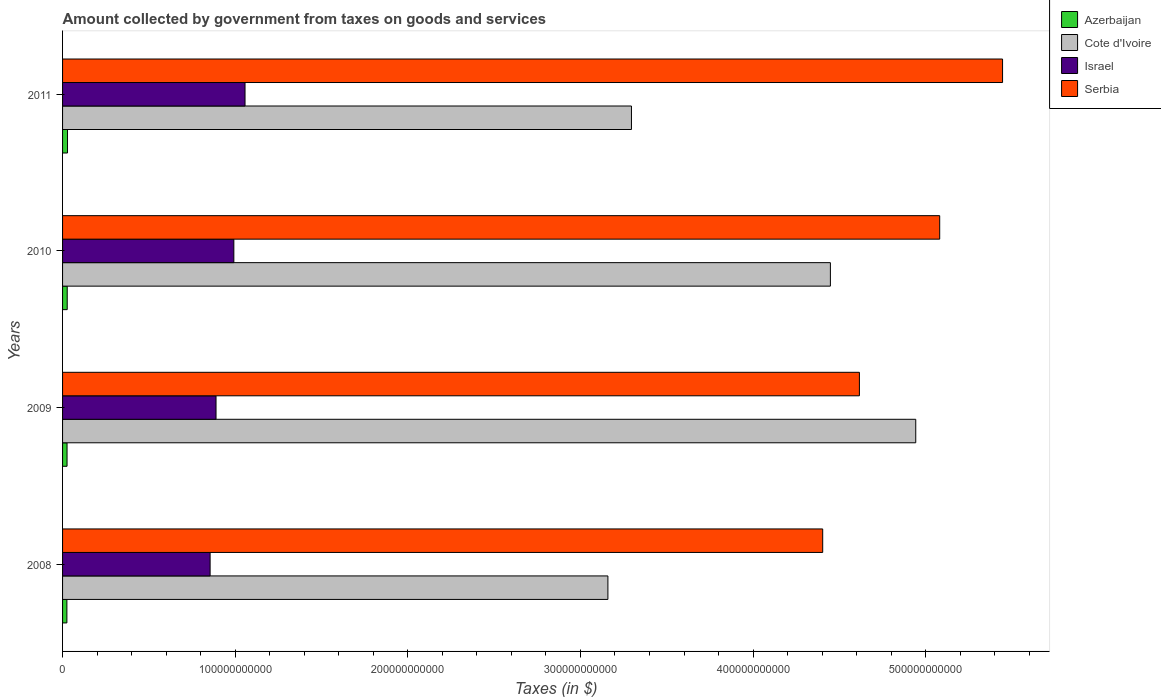How many bars are there on the 4th tick from the bottom?
Offer a very short reply. 4. What is the amount collected by government from taxes on goods and services in Israel in 2009?
Provide a succinct answer. 8.89e+1. Across all years, what is the maximum amount collected by government from taxes on goods and services in Azerbaijan?
Ensure brevity in your answer.  2.87e+09. Across all years, what is the minimum amount collected by government from taxes on goods and services in Azerbaijan?
Ensure brevity in your answer.  2.50e+09. What is the total amount collected by government from taxes on goods and services in Israel in the graph?
Keep it short and to the point. 3.79e+11. What is the difference between the amount collected by government from taxes on goods and services in Azerbaijan in 2008 and that in 2011?
Offer a terse response. -3.62e+08. What is the difference between the amount collected by government from taxes on goods and services in Azerbaijan in 2010 and the amount collected by government from taxes on goods and services in Cote d'Ivoire in 2011?
Make the answer very short. -3.27e+11. What is the average amount collected by government from taxes on goods and services in Azerbaijan per year?
Give a very brief answer. 2.66e+09. In the year 2009, what is the difference between the amount collected by government from taxes on goods and services in Serbia and amount collected by government from taxes on goods and services in Azerbaijan?
Provide a short and direct response. 4.59e+11. In how many years, is the amount collected by government from taxes on goods and services in Israel greater than 280000000000 $?
Provide a short and direct response. 0. What is the ratio of the amount collected by government from taxes on goods and services in Cote d'Ivoire in 2009 to that in 2010?
Your answer should be compact. 1.11. Is the difference between the amount collected by government from taxes on goods and services in Serbia in 2008 and 2009 greater than the difference between the amount collected by government from taxes on goods and services in Azerbaijan in 2008 and 2009?
Offer a terse response. No. What is the difference between the highest and the second highest amount collected by government from taxes on goods and services in Cote d'Ivoire?
Provide a short and direct response. 4.94e+1. What is the difference between the highest and the lowest amount collected by government from taxes on goods and services in Azerbaijan?
Keep it short and to the point. 3.62e+08. In how many years, is the amount collected by government from taxes on goods and services in Cote d'Ivoire greater than the average amount collected by government from taxes on goods and services in Cote d'Ivoire taken over all years?
Make the answer very short. 2. Is the sum of the amount collected by government from taxes on goods and services in Israel in 2008 and 2011 greater than the maximum amount collected by government from taxes on goods and services in Cote d'Ivoire across all years?
Keep it short and to the point. No. Is it the case that in every year, the sum of the amount collected by government from taxes on goods and services in Serbia and amount collected by government from taxes on goods and services in Israel is greater than the sum of amount collected by government from taxes on goods and services in Cote d'Ivoire and amount collected by government from taxes on goods and services in Azerbaijan?
Make the answer very short. Yes. What does the 1st bar from the bottom in 2008 represents?
Your answer should be compact. Azerbaijan. How many years are there in the graph?
Provide a short and direct response. 4. What is the difference between two consecutive major ticks on the X-axis?
Make the answer very short. 1.00e+11. Does the graph contain any zero values?
Give a very brief answer. No. Does the graph contain grids?
Your answer should be compact. No. How many legend labels are there?
Offer a very short reply. 4. How are the legend labels stacked?
Give a very brief answer. Vertical. What is the title of the graph?
Offer a terse response. Amount collected by government from taxes on goods and services. What is the label or title of the X-axis?
Provide a short and direct response. Taxes (in $). What is the Taxes (in $) of Azerbaijan in 2008?
Provide a succinct answer. 2.50e+09. What is the Taxes (in $) in Cote d'Ivoire in 2008?
Offer a very short reply. 3.16e+11. What is the Taxes (in $) in Israel in 2008?
Ensure brevity in your answer.  8.55e+1. What is the Taxes (in $) of Serbia in 2008?
Your answer should be very brief. 4.40e+11. What is the Taxes (in $) of Azerbaijan in 2009?
Provide a succinct answer. 2.59e+09. What is the Taxes (in $) of Cote d'Ivoire in 2009?
Provide a short and direct response. 4.94e+11. What is the Taxes (in $) of Israel in 2009?
Offer a very short reply. 8.89e+1. What is the Taxes (in $) of Serbia in 2009?
Provide a short and direct response. 4.62e+11. What is the Taxes (in $) of Azerbaijan in 2010?
Offer a very short reply. 2.70e+09. What is the Taxes (in $) of Cote d'Ivoire in 2010?
Give a very brief answer. 4.45e+11. What is the Taxes (in $) of Israel in 2010?
Provide a short and direct response. 9.92e+1. What is the Taxes (in $) in Serbia in 2010?
Offer a terse response. 5.08e+11. What is the Taxes (in $) in Azerbaijan in 2011?
Give a very brief answer. 2.87e+09. What is the Taxes (in $) of Cote d'Ivoire in 2011?
Make the answer very short. 3.30e+11. What is the Taxes (in $) in Israel in 2011?
Your answer should be very brief. 1.06e+11. What is the Taxes (in $) of Serbia in 2011?
Offer a terse response. 5.45e+11. Across all years, what is the maximum Taxes (in $) of Azerbaijan?
Keep it short and to the point. 2.87e+09. Across all years, what is the maximum Taxes (in $) of Cote d'Ivoire?
Give a very brief answer. 4.94e+11. Across all years, what is the maximum Taxes (in $) of Israel?
Make the answer very short. 1.06e+11. Across all years, what is the maximum Taxes (in $) in Serbia?
Offer a terse response. 5.45e+11. Across all years, what is the minimum Taxes (in $) in Azerbaijan?
Offer a very short reply. 2.50e+09. Across all years, what is the minimum Taxes (in $) of Cote d'Ivoire?
Make the answer very short. 3.16e+11. Across all years, what is the minimum Taxes (in $) in Israel?
Ensure brevity in your answer.  8.55e+1. Across all years, what is the minimum Taxes (in $) in Serbia?
Provide a short and direct response. 4.40e+11. What is the total Taxes (in $) in Azerbaijan in the graph?
Ensure brevity in your answer.  1.07e+1. What is the total Taxes (in $) of Cote d'Ivoire in the graph?
Make the answer very short. 1.58e+12. What is the total Taxes (in $) in Israel in the graph?
Provide a short and direct response. 3.79e+11. What is the total Taxes (in $) of Serbia in the graph?
Your answer should be compact. 1.95e+12. What is the difference between the Taxes (in $) in Azerbaijan in 2008 and that in 2009?
Offer a very short reply. -9.02e+07. What is the difference between the Taxes (in $) of Cote d'Ivoire in 2008 and that in 2009?
Keep it short and to the point. -1.78e+11. What is the difference between the Taxes (in $) of Israel in 2008 and that in 2009?
Offer a very short reply. -3.43e+09. What is the difference between the Taxes (in $) in Serbia in 2008 and that in 2009?
Ensure brevity in your answer.  -2.13e+1. What is the difference between the Taxes (in $) of Azerbaijan in 2008 and that in 2010?
Provide a succinct answer. -1.93e+08. What is the difference between the Taxes (in $) of Cote d'Ivoire in 2008 and that in 2010?
Provide a succinct answer. -1.29e+11. What is the difference between the Taxes (in $) in Israel in 2008 and that in 2010?
Make the answer very short. -1.38e+1. What is the difference between the Taxes (in $) of Serbia in 2008 and that in 2010?
Ensure brevity in your answer.  -6.78e+1. What is the difference between the Taxes (in $) in Azerbaijan in 2008 and that in 2011?
Keep it short and to the point. -3.62e+08. What is the difference between the Taxes (in $) of Cote d'Ivoire in 2008 and that in 2011?
Your answer should be very brief. -1.36e+1. What is the difference between the Taxes (in $) in Israel in 2008 and that in 2011?
Ensure brevity in your answer.  -2.02e+1. What is the difference between the Taxes (in $) in Serbia in 2008 and that in 2011?
Give a very brief answer. -1.04e+11. What is the difference between the Taxes (in $) in Azerbaijan in 2009 and that in 2010?
Keep it short and to the point. -1.03e+08. What is the difference between the Taxes (in $) of Cote d'Ivoire in 2009 and that in 2010?
Offer a terse response. 4.94e+1. What is the difference between the Taxes (in $) of Israel in 2009 and that in 2010?
Provide a short and direct response. -1.03e+1. What is the difference between the Taxes (in $) of Serbia in 2009 and that in 2010?
Keep it short and to the point. -4.65e+1. What is the difference between the Taxes (in $) of Azerbaijan in 2009 and that in 2011?
Provide a short and direct response. -2.72e+08. What is the difference between the Taxes (in $) in Cote d'Ivoire in 2009 and that in 2011?
Keep it short and to the point. 1.65e+11. What is the difference between the Taxes (in $) in Israel in 2009 and that in 2011?
Provide a short and direct response. -1.68e+1. What is the difference between the Taxes (in $) of Serbia in 2009 and that in 2011?
Provide a short and direct response. -8.29e+1. What is the difference between the Taxes (in $) of Azerbaijan in 2010 and that in 2011?
Your response must be concise. -1.70e+08. What is the difference between the Taxes (in $) in Cote d'Ivoire in 2010 and that in 2011?
Your answer should be very brief. 1.15e+11. What is the difference between the Taxes (in $) in Israel in 2010 and that in 2011?
Ensure brevity in your answer.  -6.48e+09. What is the difference between the Taxes (in $) in Serbia in 2010 and that in 2011?
Your response must be concise. -3.64e+1. What is the difference between the Taxes (in $) in Azerbaijan in 2008 and the Taxes (in $) in Cote d'Ivoire in 2009?
Provide a succinct answer. -4.92e+11. What is the difference between the Taxes (in $) of Azerbaijan in 2008 and the Taxes (in $) of Israel in 2009?
Provide a succinct answer. -8.64e+1. What is the difference between the Taxes (in $) in Azerbaijan in 2008 and the Taxes (in $) in Serbia in 2009?
Make the answer very short. -4.59e+11. What is the difference between the Taxes (in $) in Cote d'Ivoire in 2008 and the Taxes (in $) in Israel in 2009?
Offer a very short reply. 2.27e+11. What is the difference between the Taxes (in $) in Cote d'Ivoire in 2008 and the Taxes (in $) in Serbia in 2009?
Your response must be concise. -1.46e+11. What is the difference between the Taxes (in $) in Israel in 2008 and the Taxes (in $) in Serbia in 2009?
Ensure brevity in your answer.  -3.76e+11. What is the difference between the Taxes (in $) of Azerbaijan in 2008 and the Taxes (in $) of Cote d'Ivoire in 2010?
Your answer should be compact. -4.42e+11. What is the difference between the Taxes (in $) of Azerbaijan in 2008 and the Taxes (in $) of Israel in 2010?
Make the answer very short. -9.67e+1. What is the difference between the Taxes (in $) of Azerbaijan in 2008 and the Taxes (in $) of Serbia in 2010?
Ensure brevity in your answer.  -5.06e+11. What is the difference between the Taxes (in $) in Cote d'Ivoire in 2008 and the Taxes (in $) in Israel in 2010?
Ensure brevity in your answer.  2.17e+11. What is the difference between the Taxes (in $) in Cote d'Ivoire in 2008 and the Taxes (in $) in Serbia in 2010?
Your answer should be compact. -1.92e+11. What is the difference between the Taxes (in $) in Israel in 2008 and the Taxes (in $) in Serbia in 2010?
Provide a succinct answer. -4.23e+11. What is the difference between the Taxes (in $) of Azerbaijan in 2008 and the Taxes (in $) of Cote d'Ivoire in 2011?
Keep it short and to the point. -3.27e+11. What is the difference between the Taxes (in $) in Azerbaijan in 2008 and the Taxes (in $) in Israel in 2011?
Your response must be concise. -1.03e+11. What is the difference between the Taxes (in $) in Azerbaijan in 2008 and the Taxes (in $) in Serbia in 2011?
Give a very brief answer. -5.42e+11. What is the difference between the Taxes (in $) in Cote d'Ivoire in 2008 and the Taxes (in $) in Israel in 2011?
Your response must be concise. 2.10e+11. What is the difference between the Taxes (in $) in Cote d'Ivoire in 2008 and the Taxes (in $) in Serbia in 2011?
Ensure brevity in your answer.  -2.29e+11. What is the difference between the Taxes (in $) in Israel in 2008 and the Taxes (in $) in Serbia in 2011?
Make the answer very short. -4.59e+11. What is the difference between the Taxes (in $) of Azerbaijan in 2009 and the Taxes (in $) of Cote d'Ivoire in 2010?
Ensure brevity in your answer.  -4.42e+11. What is the difference between the Taxes (in $) in Azerbaijan in 2009 and the Taxes (in $) in Israel in 2010?
Your response must be concise. -9.66e+1. What is the difference between the Taxes (in $) in Azerbaijan in 2009 and the Taxes (in $) in Serbia in 2010?
Provide a succinct answer. -5.06e+11. What is the difference between the Taxes (in $) of Cote d'Ivoire in 2009 and the Taxes (in $) of Israel in 2010?
Provide a short and direct response. 3.95e+11. What is the difference between the Taxes (in $) of Cote d'Ivoire in 2009 and the Taxes (in $) of Serbia in 2010?
Your response must be concise. -1.39e+1. What is the difference between the Taxes (in $) of Israel in 2009 and the Taxes (in $) of Serbia in 2010?
Make the answer very short. -4.19e+11. What is the difference between the Taxes (in $) of Azerbaijan in 2009 and the Taxes (in $) of Cote d'Ivoire in 2011?
Your response must be concise. -3.27e+11. What is the difference between the Taxes (in $) of Azerbaijan in 2009 and the Taxes (in $) of Israel in 2011?
Make the answer very short. -1.03e+11. What is the difference between the Taxes (in $) of Azerbaijan in 2009 and the Taxes (in $) of Serbia in 2011?
Give a very brief answer. -5.42e+11. What is the difference between the Taxes (in $) in Cote d'Ivoire in 2009 and the Taxes (in $) in Israel in 2011?
Your answer should be compact. 3.89e+11. What is the difference between the Taxes (in $) in Cote d'Ivoire in 2009 and the Taxes (in $) in Serbia in 2011?
Provide a succinct answer. -5.03e+1. What is the difference between the Taxes (in $) in Israel in 2009 and the Taxes (in $) in Serbia in 2011?
Keep it short and to the point. -4.56e+11. What is the difference between the Taxes (in $) of Azerbaijan in 2010 and the Taxes (in $) of Cote d'Ivoire in 2011?
Make the answer very short. -3.27e+11. What is the difference between the Taxes (in $) of Azerbaijan in 2010 and the Taxes (in $) of Israel in 2011?
Ensure brevity in your answer.  -1.03e+11. What is the difference between the Taxes (in $) in Azerbaijan in 2010 and the Taxes (in $) in Serbia in 2011?
Provide a short and direct response. -5.42e+11. What is the difference between the Taxes (in $) of Cote d'Ivoire in 2010 and the Taxes (in $) of Israel in 2011?
Offer a very short reply. 3.39e+11. What is the difference between the Taxes (in $) in Cote d'Ivoire in 2010 and the Taxes (in $) in Serbia in 2011?
Provide a succinct answer. -9.97e+1. What is the difference between the Taxes (in $) of Israel in 2010 and the Taxes (in $) of Serbia in 2011?
Provide a short and direct response. -4.45e+11. What is the average Taxes (in $) of Azerbaijan per year?
Your response must be concise. 2.66e+09. What is the average Taxes (in $) of Cote d'Ivoire per year?
Offer a terse response. 3.96e+11. What is the average Taxes (in $) in Israel per year?
Provide a succinct answer. 9.48e+1. What is the average Taxes (in $) in Serbia per year?
Make the answer very short. 4.89e+11. In the year 2008, what is the difference between the Taxes (in $) in Azerbaijan and Taxes (in $) in Cote d'Ivoire?
Offer a terse response. -3.13e+11. In the year 2008, what is the difference between the Taxes (in $) of Azerbaijan and Taxes (in $) of Israel?
Provide a succinct answer. -8.30e+1. In the year 2008, what is the difference between the Taxes (in $) of Azerbaijan and Taxes (in $) of Serbia?
Offer a terse response. -4.38e+11. In the year 2008, what is the difference between the Taxes (in $) of Cote d'Ivoire and Taxes (in $) of Israel?
Make the answer very short. 2.30e+11. In the year 2008, what is the difference between the Taxes (in $) of Cote d'Ivoire and Taxes (in $) of Serbia?
Keep it short and to the point. -1.24e+11. In the year 2008, what is the difference between the Taxes (in $) of Israel and Taxes (in $) of Serbia?
Offer a terse response. -3.55e+11. In the year 2009, what is the difference between the Taxes (in $) of Azerbaijan and Taxes (in $) of Cote d'Ivoire?
Your response must be concise. -4.92e+11. In the year 2009, what is the difference between the Taxes (in $) in Azerbaijan and Taxes (in $) in Israel?
Offer a terse response. -8.63e+1. In the year 2009, what is the difference between the Taxes (in $) in Azerbaijan and Taxes (in $) in Serbia?
Offer a very short reply. -4.59e+11. In the year 2009, what is the difference between the Taxes (in $) of Cote d'Ivoire and Taxes (in $) of Israel?
Offer a terse response. 4.05e+11. In the year 2009, what is the difference between the Taxes (in $) of Cote d'Ivoire and Taxes (in $) of Serbia?
Give a very brief answer. 3.26e+1. In the year 2009, what is the difference between the Taxes (in $) of Israel and Taxes (in $) of Serbia?
Make the answer very short. -3.73e+11. In the year 2010, what is the difference between the Taxes (in $) of Azerbaijan and Taxes (in $) of Cote d'Ivoire?
Your answer should be very brief. -4.42e+11. In the year 2010, what is the difference between the Taxes (in $) of Azerbaijan and Taxes (in $) of Israel?
Offer a terse response. -9.65e+1. In the year 2010, what is the difference between the Taxes (in $) in Azerbaijan and Taxes (in $) in Serbia?
Make the answer very short. -5.05e+11. In the year 2010, what is the difference between the Taxes (in $) of Cote d'Ivoire and Taxes (in $) of Israel?
Offer a terse response. 3.46e+11. In the year 2010, what is the difference between the Taxes (in $) of Cote d'Ivoire and Taxes (in $) of Serbia?
Provide a succinct answer. -6.33e+1. In the year 2010, what is the difference between the Taxes (in $) in Israel and Taxes (in $) in Serbia?
Your response must be concise. -4.09e+11. In the year 2011, what is the difference between the Taxes (in $) of Azerbaijan and Taxes (in $) of Cote d'Ivoire?
Provide a succinct answer. -3.27e+11. In the year 2011, what is the difference between the Taxes (in $) in Azerbaijan and Taxes (in $) in Israel?
Offer a very short reply. -1.03e+11. In the year 2011, what is the difference between the Taxes (in $) of Azerbaijan and Taxes (in $) of Serbia?
Keep it short and to the point. -5.42e+11. In the year 2011, what is the difference between the Taxes (in $) of Cote d'Ivoire and Taxes (in $) of Israel?
Make the answer very short. 2.24e+11. In the year 2011, what is the difference between the Taxes (in $) of Cote d'Ivoire and Taxes (in $) of Serbia?
Ensure brevity in your answer.  -2.15e+11. In the year 2011, what is the difference between the Taxes (in $) of Israel and Taxes (in $) of Serbia?
Give a very brief answer. -4.39e+11. What is the ratio of the Taxes (in $) in Azerbaijan in 2008 to that in 2009?
Make the answer very short. 0.97. What is the ratio of the Taxes (in $) of Cote d'Ivoire in 2008 to that in 2009?
Keep it short and to the point. 0.64. What is the ratio of the Taxes (in $) of Israel in 2008 to that in 2009?
Offer a very short reply. 0.96. What is the ratio of the Taxes (in $) of Serbia in 2008 to that in 2009?
Your answer should be compact. 0.95. What is the ratio of the Taxes (in $) in Azerbaijan in 2008 to that in 2010?
Your answer should be compact. 0.93. What is the ratio of the Taxes (in $) in Cote d'Ivoire in 2008 to that in 2010?
Your response must be concise. 0.71. What is the ratio of the Taxes (in $) in Israel in 2008 to that in 2010?
Offer a terse response. 0.86. What is the ratio of the Taxes (in $) in Serbia in 2008 to that in 2010?
Offer a very short reply. 0.87. What is the ratio of the Taxes (in $) in Azerbaijan in 2008 to that in 2011?
Provide a succinct answer. 0.87. What is the ratio of the Taxes (in $) of Cote d'Ivoire in 2008 to that in 2011?
Keep it short and to the point. 0.96. What is the ratio of the Taxes (in $) in Israel in 2008 to that in 2011?
Your answer should be compact. 0.81. What is the ratio of the Taxes (in $) of Serbia in 2008 to that in 2011?
Keep it short and to the point. 0.81. What is the ratio of the Taxes (in $) of Azerbaijan in 2009 to that in 2010?
Your response must be concise. 0.96. What is the ratio of the Taxes (in $) of Cote d'Ivoire in 2009 to that in 2010?
Your answer should be very brief. 1.11. What is the ratio of the Taxes (in $) of Israel in 2009 to that in 2010?
Give a very brief answer. 0.9. What is the ratio of the Taxes (in $) of Serbia in 2009 to that in 2010?
Provide a succinct answer. 0.91. What is the ratio of the Taxes (in $) in Azerbaijan in 2009 to that in 2011?
Provide a succinct answer. 0.91. What is the ratio of the Taxes (in $) of Cote d'Ivoire in 2009 to that in 2011?
Give a very brief answer. 1.5. What is the ratio of the Taxes (in $) in Israel in 2009 to that in 2011?
Ensure brevity in your answer.  0.84. What is the ratio of the Taxes (in $) in Serbia in 2009 to that in 2011?
Your response must be concise. 0.85. What is the ratio of the Taxes (in $) in Azerbaijan in 2010 to that in 2011?
Ensure brevity in your answer.  0.94. What is the ratio of the Taxes (in $) of Cote d'Ivoire in 2010 to that in 2011?
Your response must be concise. 1.35. What is the ratio of the Taxes (in $) of Israel in 2010 to that in 2011?
Keep it short and to the point. 0.94. What is the ratio of the Taxes (in $) in Serbia in 2010 to that in 2011?
Provide a succinct answer. 0.93. What is the difference between the highest and the second highest Taxes (in $) of Azerbaijan?
Keep it short and to the point. 1.70e+08. What is the difference between the highest and the second highest Taxes (in $) in Cote d'Ivoire?
Give a very brief answer. 4.94e+1. What is the difference between the highest and the second highest Taxes (in $) of Israel?
Offer a terse response. 6.48e+09. What is the difference between the highest and the second highest Taxes (in $) of Serbia?
Offer a terse response. 3.64e+1. What is the difference between the highest and the lowest Taxes (in $) of Azerbaijan?
Make the answer very short. 3.62e+08. What is the difference between the highest and the lowest Taxes (in $) in Cote d'Ivoire?
Make the answer very short. 1.78e+11. What is the difference between the highest and the lowest Taxes (in $) in Israel?
Provide a short and direct response. 2.02e+1. What is the difference between the highest and the lowest Taxes (in $) in Serbia?
Provide a succinct answer. 1.04e+11. 